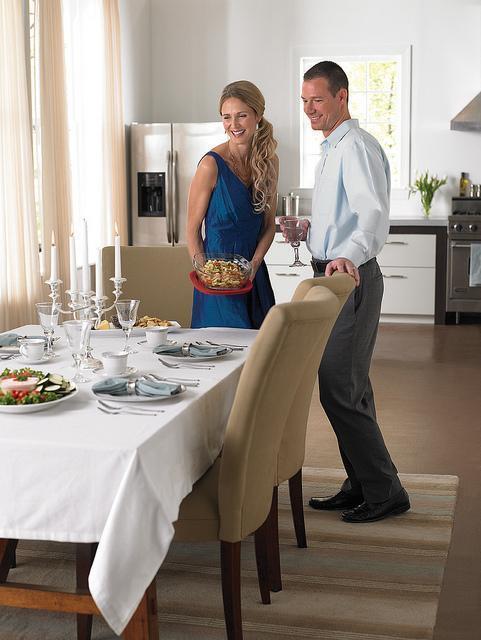What is the name of dining candles?
Pick the correct solution from the four options below to address the question.
Options: Tea light, votives, taper candles, pillar candles. Votives. 